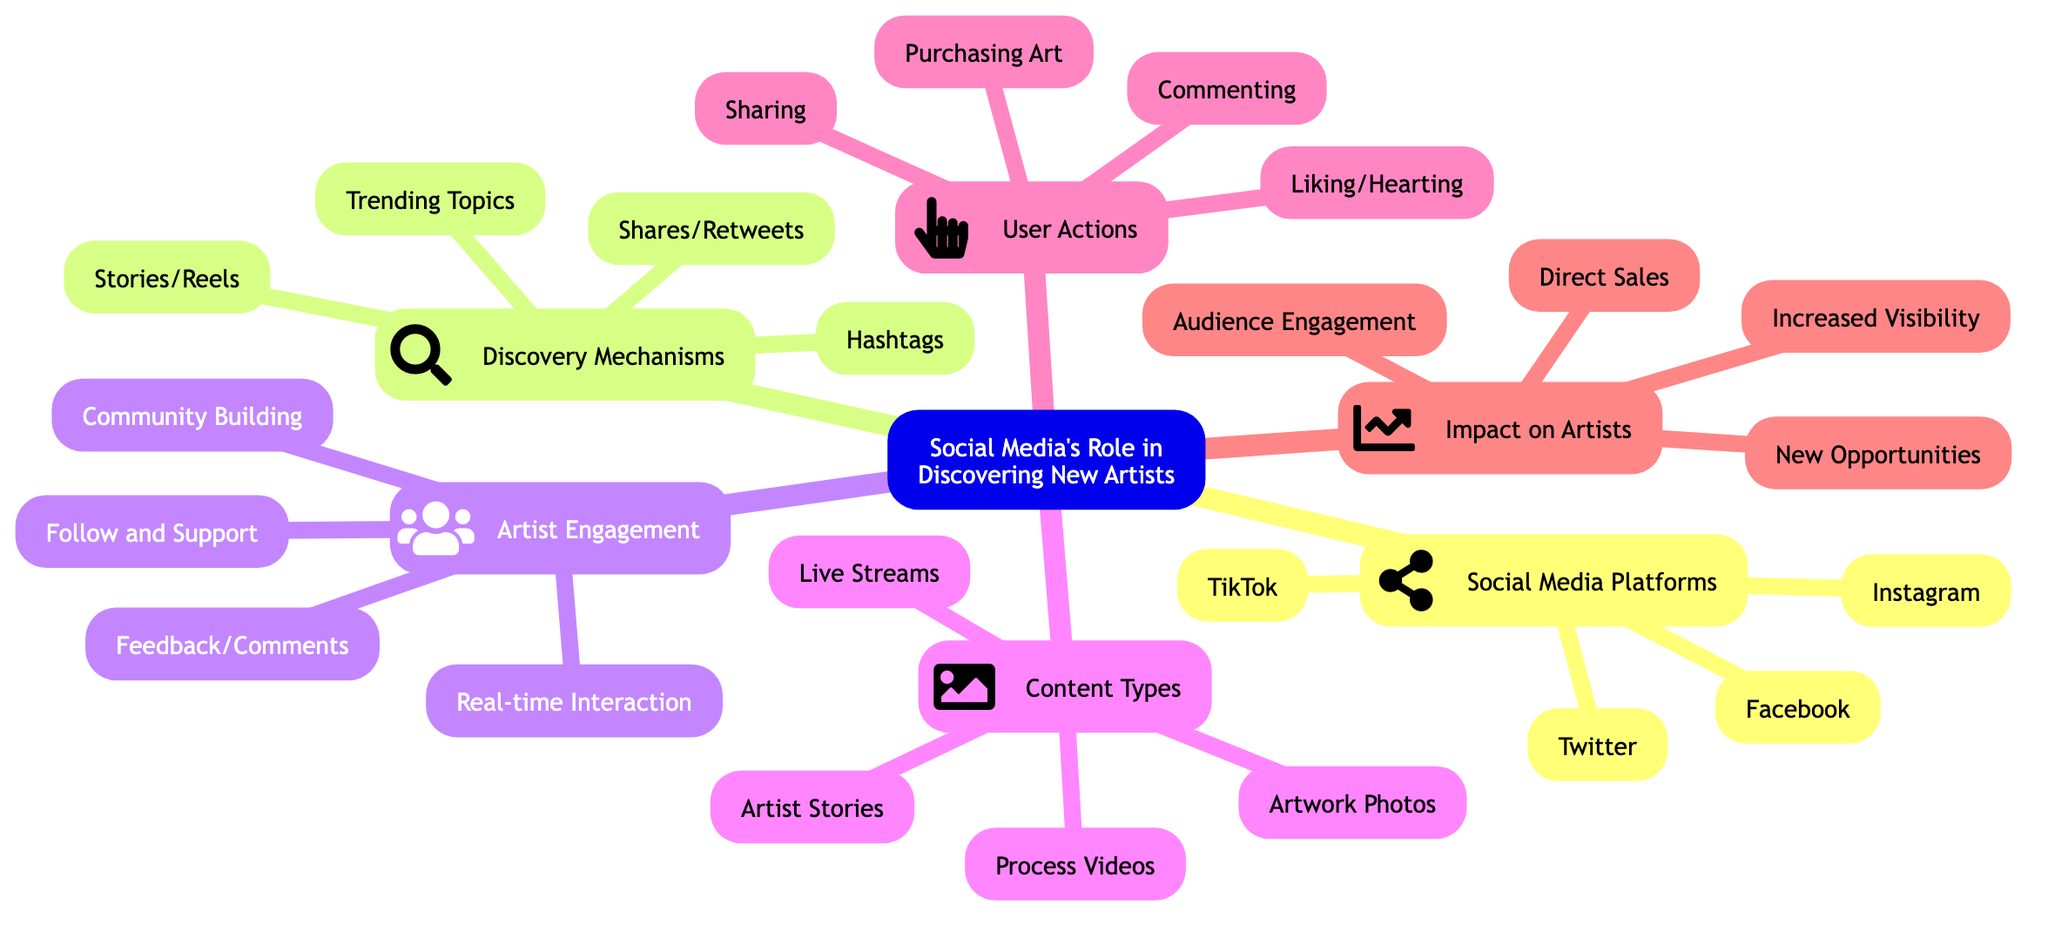What are the four platforms mentioned in the diagram? The diagram lists four social media platforms under the "Social Media Platforms" node: Instagram, Facebook, Twitter, and TikTok.
Answer: Instagram, Facebook, Twitter, TikTok Which content type is related to "Live Streams"? "Live Streams" is mentioned under the "Content Types" node, indicating that it is one of the examples of content types shared by artists on social media.
Answer: Live Streams How do users express support according to the diagram? According to the "User Actions" node, support is expressed through "Liking/Hearting," indicating a way users show appreciation for art.
Answer: Liking/Hearting What promotes content through hashtags? Under the "Discovery Mechanisms" node, it states that "Hashtags" promote content, showcasing a method for increasing visibility of artists' work.
Answer: Hashtags Which node is strengthened by community building? The "Artist Engagement" node states that "Community Building" is strengthened by user interactions, highlighting how artists connect with their followers.
Answer: Artist Engagement How many discovery mechanisms are listed in the diagram? The "Discovery Mechanisms" node contains four listed mechanisms: Hashtags, Trending Topics, Shares/Retweets, and Stories/Reels, thus the total is four.
Answer: Four What leads to new opportunities for artists? The "Impact on Artists" node identifies that increased visibility results in new opportunities, showing how social media can benefit artists.
Answer: Increased Visibility Name one type of content that can include process videos. The "Content Types" node shows that "Process Videos" can be categorized under what artists share on social media, indicating another format they use.
Answer: Process Videos What facilitates feedback/comments from users? According to the "Artist Engagement" node, "Feedback/Comments" are facilitated within the artist's engagement with their audience, helping to create connections.
Answer: Feedback/Comments 